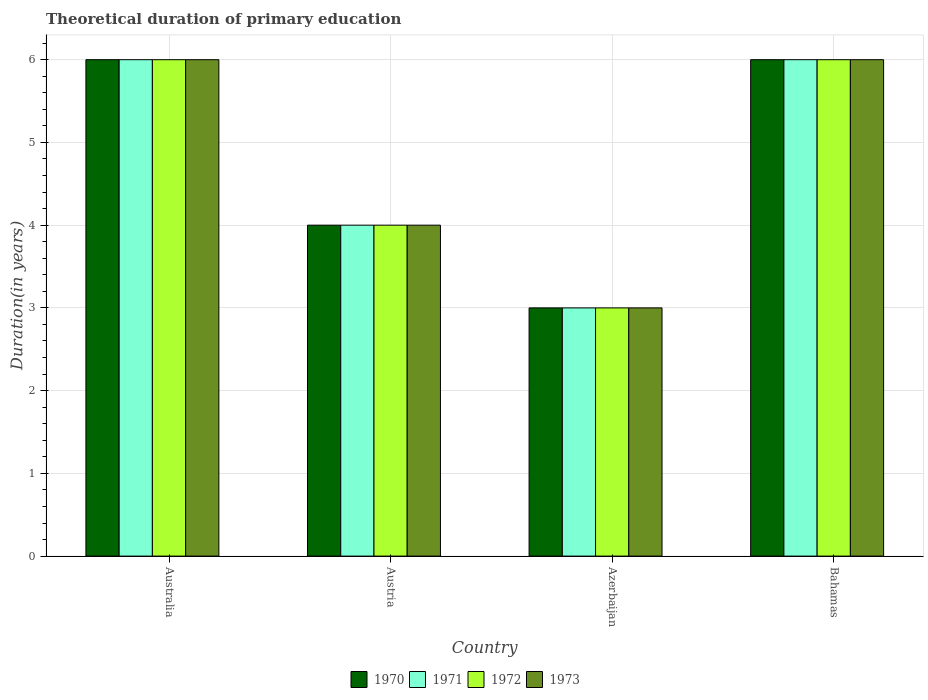How many groups of bars are there?
Make the answer very short. 4. Are the number of bars on each tick of the X-axis equal?
Provide a short and direct response. Yes. How many bars are there on the 2nd tick from the right?
Provide a succinct answer. 4. What is the label of the 3rd group of bars from the left?
Ensure brevity in your answer.  Azerbaijan. Across all countries, what is the minimum total theoretical duration of primary education in 1970?
Your answer should be very brief. 3. In which country was the total theoretical duration of primary education in 1971 minimum?
Give a very brief answer. Azerbaijan. What is the difference between the total theoretical duration of primary education in 1971 in Azerbaijan and that in Bahamas?
Your response must be concise. -3. What is the average total theoretical duration of primary education in 1972 per country?
Your answer should be very brief. 4.75. What is the difference between the total theoretical duration of primary education of/in 1973 and total theoretical duration of primary education of/in 1971 in Bahamas?
Provide a succinct answer. 0. What is the ratio of the total theoretical duration of primary education in 1972 in Austria to that in Bahamas?
Your response must be concise. 0.67. What is the difference between the highest and the second highest total theoretical duration of primary education in 1971?
Give a very brief answer. -2. What is the difference between the highest and the lowest total theoretical duration of primary education in 1970?
Keep it short and to the point. 3. Is the sum of the total theoretical duration of primary education in 1973 in Azerbaijan and Bahamas greater than the maximum total theoretical duration of primary education in 1971 across all countries?
Keep it short and to the point. Yes. What does the 4th bar from the left in Azerbaijan represents?
Provide a short and direct response. 1973. What does the 3rd bar from the right in Bahamas represents?
Give a very brief answer. 1971. Is it the case that in every country, the sum of the total theoretical duration of primary education in 1970 and total theoretical duration of primary education in 1973 is greater than the total theoretical duration of primary education in 1971?
Keep it short and to the point. Yes. How many bars are there?
Your answer should be compact. 16. What is the difference between two consecutive major ticks on the Y-axis?
Your response must be concise. 1. Are the values on the major ticks of Y-axis written in scientific E-notation?
Keep it short and to the point. No. Where does the legend appear in the graph?
Provide a succinct answer. Bottom center. How many legend labels are there?
Your response must be concise. 4. What is the title of the graph?
Your response must be concise. Theoretical duration of primary education. Does "1988" appear as one of the legend labels in the graph?
Your answer should be compact. No. What is the label or title of the Y-axis?
Provide a short and direct response. Duration(in years). What is the Duration(in years) in 1970 in Australia?
Give a very brief answer. 6. What is the Duration(in years) of 1973 in Australia?
Give a very brief answer. 6. What is the Duration(in years) of 1971 in Azerbaijan?
Keep it short and to the point. 3. What is the Duration(in years) in 1972 in Azerbaijan?
Make the answer very short. 3. What is the Duration(in years) in 1971 in Bahamas?
Your answer should be very brief. 6. Across all countries, what is the maximum Duration(in years) of 1970?
Keep it short and to the point. 6. Across all countries, what is the maximum Duration(in years) in 1972?
Give a very brief answer. 6. Across all countries, what is the minimum Duration(in years) in 1972?
Your answer should be compact. 3. Across all countries, what is the minimum Duration(in years) in 1973?
Give a very brief answer. 3. What is the total Duration(in years) of 1970 in the graph?
Offer a very short reply. 19. What is the total Duration(in years) in 1971 in the graph?
Offer a terse response. 19. What is the total Duration(in years) of 1973 in the graph?
Make the answer very short. 19. What is the difference between the Duration(in years) of 1970 in Australia and that in Austria?
Make the answer very short. 2. What is the difference between the Duration(in years) of 1973 in Australia and that in Austria?
Your answer should be compact. 2. What is the difference between the Duration(in years) in 1971 in Australia and that in Azerbaijan?
Offer a very short reply. 3. What is the difference between the Duration(in years) in 1973 in Australia and that in Azerbaijan?
Provide a succinct answer. 3. What is the difference between the Duration(in years) in 1970 in Austria and that in Azerbaijan?
Make the answer very short. 1. What is the difference between the Duration(in years) of 1971 in Austria and that in Azerbaijan?
Offer a terse response. 1. What is the difference between the Duration(in years) in 1972 in Austria and that in Azerbaijan?
Your answer should be very brief. 1. What is the difference between the Duration(in years) in 1973 in Austria and that in Azerbaijan?
Give a very brief answer. 1. What is the difference between the Duration(in years) in 1970 in Azerbaijan and that in Bahamas?
Provide a succinct answer. -3. What is the difference between the Duration(in years) of 1972 in Azerbaijan and that in Bahamas?
Your answer should be very brief. -3. What is the difference between the Duration(in years) in 1973 in Azerbaijan and that in Bahamas?
Your response must be concise. -3. What is the difference between the Duration(in years) in 1970 in Australia and the Duration(in years) in 1971 in Austria?
Offer a terse response. 2. What is the difference between the Duration(in years) in 1970 in Australia and the Duration(in years) in 1973 in Austria?
Offer a very short reply. 2. What is the difference between the Duration(in years) in 1971 in Australia and the Duration(in years) in 1972 in Austria?
Keep it short and to the point. 2. What is the difference between the Duration(in years) of 1971 in Australia and the Duration(in years) of 1973 in Austria?
Keep it short and to the point. 2. What is the difference between the Duration(in years) in 1972 in Australia and the Duration(in years) in 1973 in Austria?
Offer a terse response. 2. What is the difference between the Duration(in years) of 1970 in Australia and the Duration(in years) of 1971 in Azerbaijan?
Your response must be concise. 3. What is the difference between the Duration(in years) of 1970 in Australia and the Duration(in years) of 1972 in Azerbaijan?
Give a very brief answer. 3. What is the difference between the Duration(in years) in 1970 in Australia and the Duration(in years) in 1973 in Azerbaijan?
Make the answer very short. 3. What is the difference between the Duration(in years) in 1971 in Australia and the Duration(in years) in 1972 in Azerbaijan?
Give a very brief answer. 3. What is the difference between the Duration(in years) of 1970 in Australia and the Duration(in years) of 1973 in Bahamas?
Provide a short and direct response. 0. What is the difference between the Duration(in years) in 1971 in Australia and the Duration(in years) in 1972 in Bahamas?
Provide a succinct answer. 0. What is the difference between the Duration(in years) in 1971 in Australia and the Duration(in years) in 1973 in Bahamas?
Offer a very short reply. 0. What is the difference between the Duration(in years) in 1971 in Austria and the Duration(in years) in 1973 in Azerbaijan?
Your response must be concise. 1. What is the difference between the Duration(in years) in 1972 in Austria and the Duration(in years) in 1973 in Azerbaijan?
Give a very brief answer. 1. What is the difference between the Duration(in years) in 1970 in Austria and the Duration(in years) in 1971 in Bahamas?
Make the answer very short. -2. What is the difference between the Duration(in years) of 1970 in Austria and the Duration(in years) of 1972 in Bahamas?
Offer a very short reply. -2. What is the difference between the Duration(in years) in 1970 in Austria and the Duration(in years) in 1973 in Bahamas?
Your response must be concise. -2. What is the difference between the Duration(in years) in 1971 in Austria and the Duration(in years) in 1972 in Bahamas?
Give a very brief answer. -2. What is the difference between the Duration(in years) in 1970 in Azerbaijan and the Duration(in years) in 1973 in Bahamas?
Make the answer very short. -3. What is the difference between the Duration(in years) in 1971 in Azerbaijan and the Duration(in years) in 1972 in Bahamas?
Your response must be concise. -3. What is the difference between the Duration(in years) in 1971 in Azerbaijan and the Duration(in years) in 1973 in Bahamas?
Your answer should be very brief. -3. What is the difference between the Duration(in years) in 1972 in Azerbaijan and the Duration(in years) in 1973 in Bahamas?
Provide a succinct answer. -3. What is the average Duration(in years) of 1970 per country?
Offer a terse response. 4.75. What is the average Duration(in years) of 1971 per country?
Keep it short and to the point. 4.75. What is the average Duration(in years) of 1972 per country?
Your response must be concise. 4.75. What is the average Duration(in years) of 1973 per country?
Offer a very short reply. 4.75. What is the difference between the Duration(in years) of 1970 and Duration(in years) of 1971 in Australia?
Provide a short and direct response. 0. What is the difference between the Duration(in years) of 1970 and Duration(in years) of 1972 in Australia?
Ensure brevity in your answer.  0. What is the difference between the Duration(in years) of 1970 and Duration(in years) of 1973 in Australia?
Offer a terse response. 0. What is the difference between the Duration(in years) of 1971 and Duration(in years) of 1973 in Australia?
Give a very brief answer. 0. What is the difference between the Duration(in years) in 1970 and Duration(in years) in 1971 in Austria?
Your answer should be compact. 0. What is the difference between the Duration(in years) in 1970 and Duration(in years) in 1973 in Austria?
Your response must be concise. 0. What is the difference between the Duration(in years) in 1971 and Duration(in years) in 1972 in Austria?
Ensure brevity in your answer.  0. What is the difference between the Duration(in years) in 1972 and Duration(in years) in 1973 in Austria?
Keep it short and to the point. 0. What is the difference between the Duration(in years) in 1970 and Duration(in years) in 1972 in Azerbaijan?
Your answer should be very brief. 0. What is the difference between the Duration(in years) in 1970 and Duration(in years) in 1973 in Azerbaijan?
Offer a terse response. 0. What is the difference between the Duration(in years) in 1971 and Duration(in years) in 1972 in Azerbaijan?
Your answer should be very brief. 0. What is the difference between the Duration(in years) of 1971 and Duration(in years) of 1973 in Azerbaijan?
Offer a terse response. 0. What is the difference between the Duration(in years) of 1972 and Duration(in years) of 1973 in Azerbaijan?
Offer a terse response. 0. What is the difference between the Duration(in years) of 1970 and Duration(in years) of 1971 in Bahamas?
Ensure brevity in your answer.  0. What is the difference between the Duration(in years) in 1970 and Duration(in years) in 1972 in Bahamas?
Your answer should be very brief. 0. What is the difference between the Duration(in years) in 1970 and Duration(in years) in 1973 in Bahamas?
Provide a short and direct response. 0. What is the difference between the Duration(in years) in 1971 and Duration(in years) in 1972 in Bahamas?
Your answer should be compact. 0. What is the ratio of the Duration(in years) of 1972 in Australia to that in Austria?
Your answer should be very brief. 1.5. What is the ratio of the Duration(in years) in 1970 in Australia to that in Azerbaijan?
Your answer should be very brief. 2. What is the ratio of the Duration(in years) in 1972 in Australia to that in Azerbaijan?
Make the answer very short. 2. What is the ratio of the Duration(in years) in 1970 in Australia to that in Bahamas?
Your answer should be very brief. 1. What is the ratio of the Duration(in years) of 1971 in Australia to that in Bahamas?
Ensure brevity in your answer.  1. What is the ratio of the Duration(in years) of 1973 in Australia to that in Bahamas?
Provide a succinct answer. 1. What is the ratio of the Duration(in years) in 1972 in Austria to that in Azerbaijan?
Provide a short and direct response. 1.33. What is the ratio of the Duration(in years) of 1973 in Austria to that in Azerbaijan?
Offer a very short reply. 1.33. What is the ratio of the Duration(in years) of 1973 in Austria to that in Bahamas?
Offer a terse response. 0.67. What is the ratio of the Duration(in years) of 1973 in Azerbaijan to that in Bahamas?
Provide a short and direct response. 0.5. What is the difference between the highest and the second highest Duration(in years) in 1970?
Make the answer very short. 0. What is the difference between the highest and the second highest Duration(in years) of 1972?
Make the answer very short. 0. What is the difference between the highest and the lowest Duration(in years) in 1971?
Your answer should be very brief. 3. 